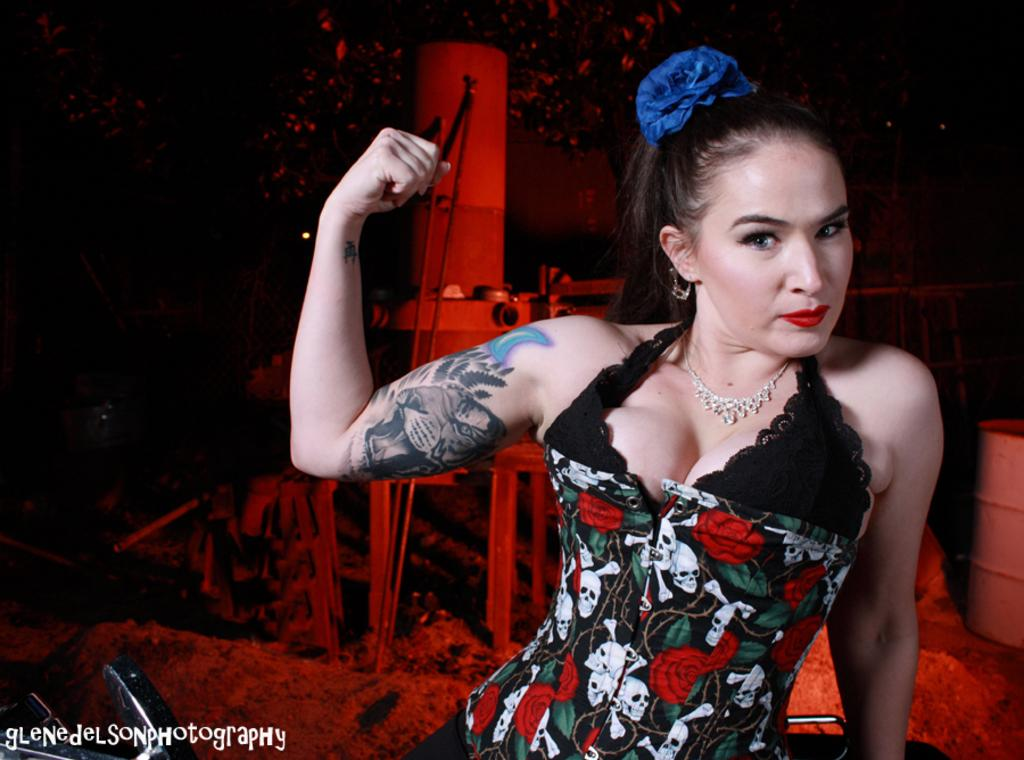Who is the main subject in the image? There is a woman in the image. What else can be seen in the image besides the woman? There are other things visible behind the woman. Is there any additional information about the image itself? Yes, there is a watermark on the image. How does the beggar in the image express their idea about the current rate of inflation? There is no beggar present in the image, nor is there any mention of an idea or rate of inflation. 